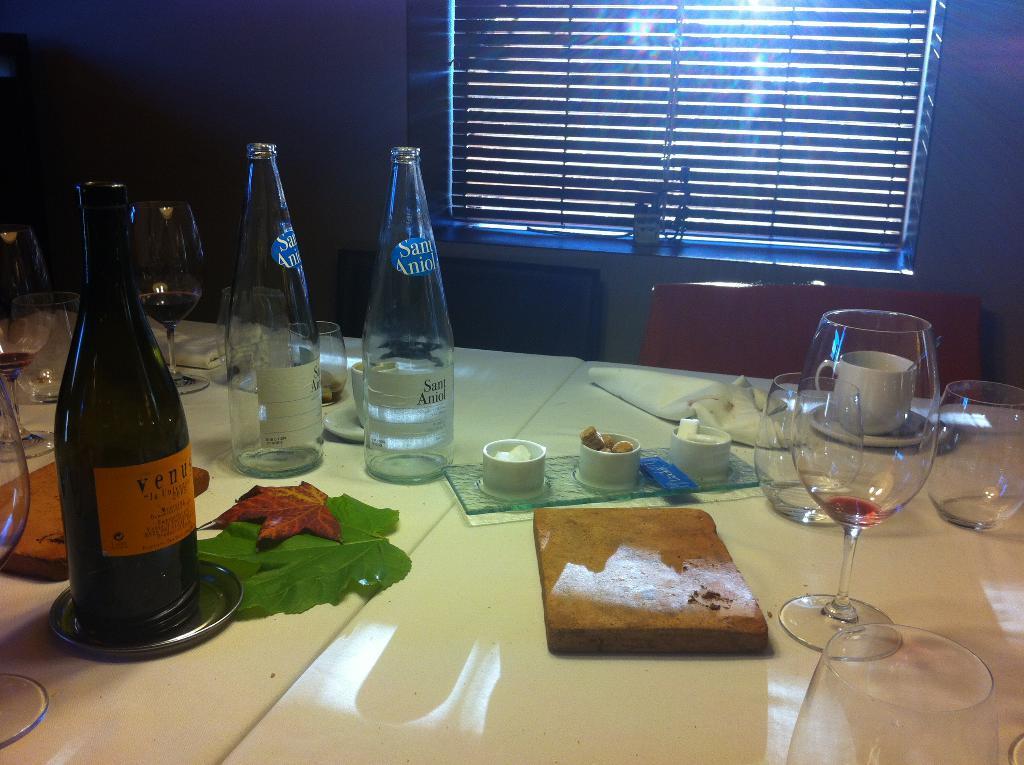Can you describe this image briefly? This is a table where a wine bottle, a glass, a piece of bread, a leaf and tissues are kept on it. 